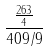<formula> <loc_0><loc_0><loc_500><loc_500>\frac { \frac { 2 6 3 } { 4 } } { 4 0 9 / 9 }</formula> 